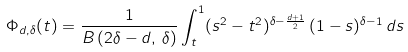<formula> <loc_0><loc_0><loc_500><loc_500>\Phi _ { d , \delta } ( t ) = \frac { 1 } { B \left ( 2 \delta - d , \, \delta \right ) } \int _ { t } ^ { 1 } ( s ^ { 2 } - t ^ { 2 } ) ^ { \delta - \frac { d + 1 } { 2 } } \, ( 1 - s ) ^ { \delta - 1 } \, d s</formula> 